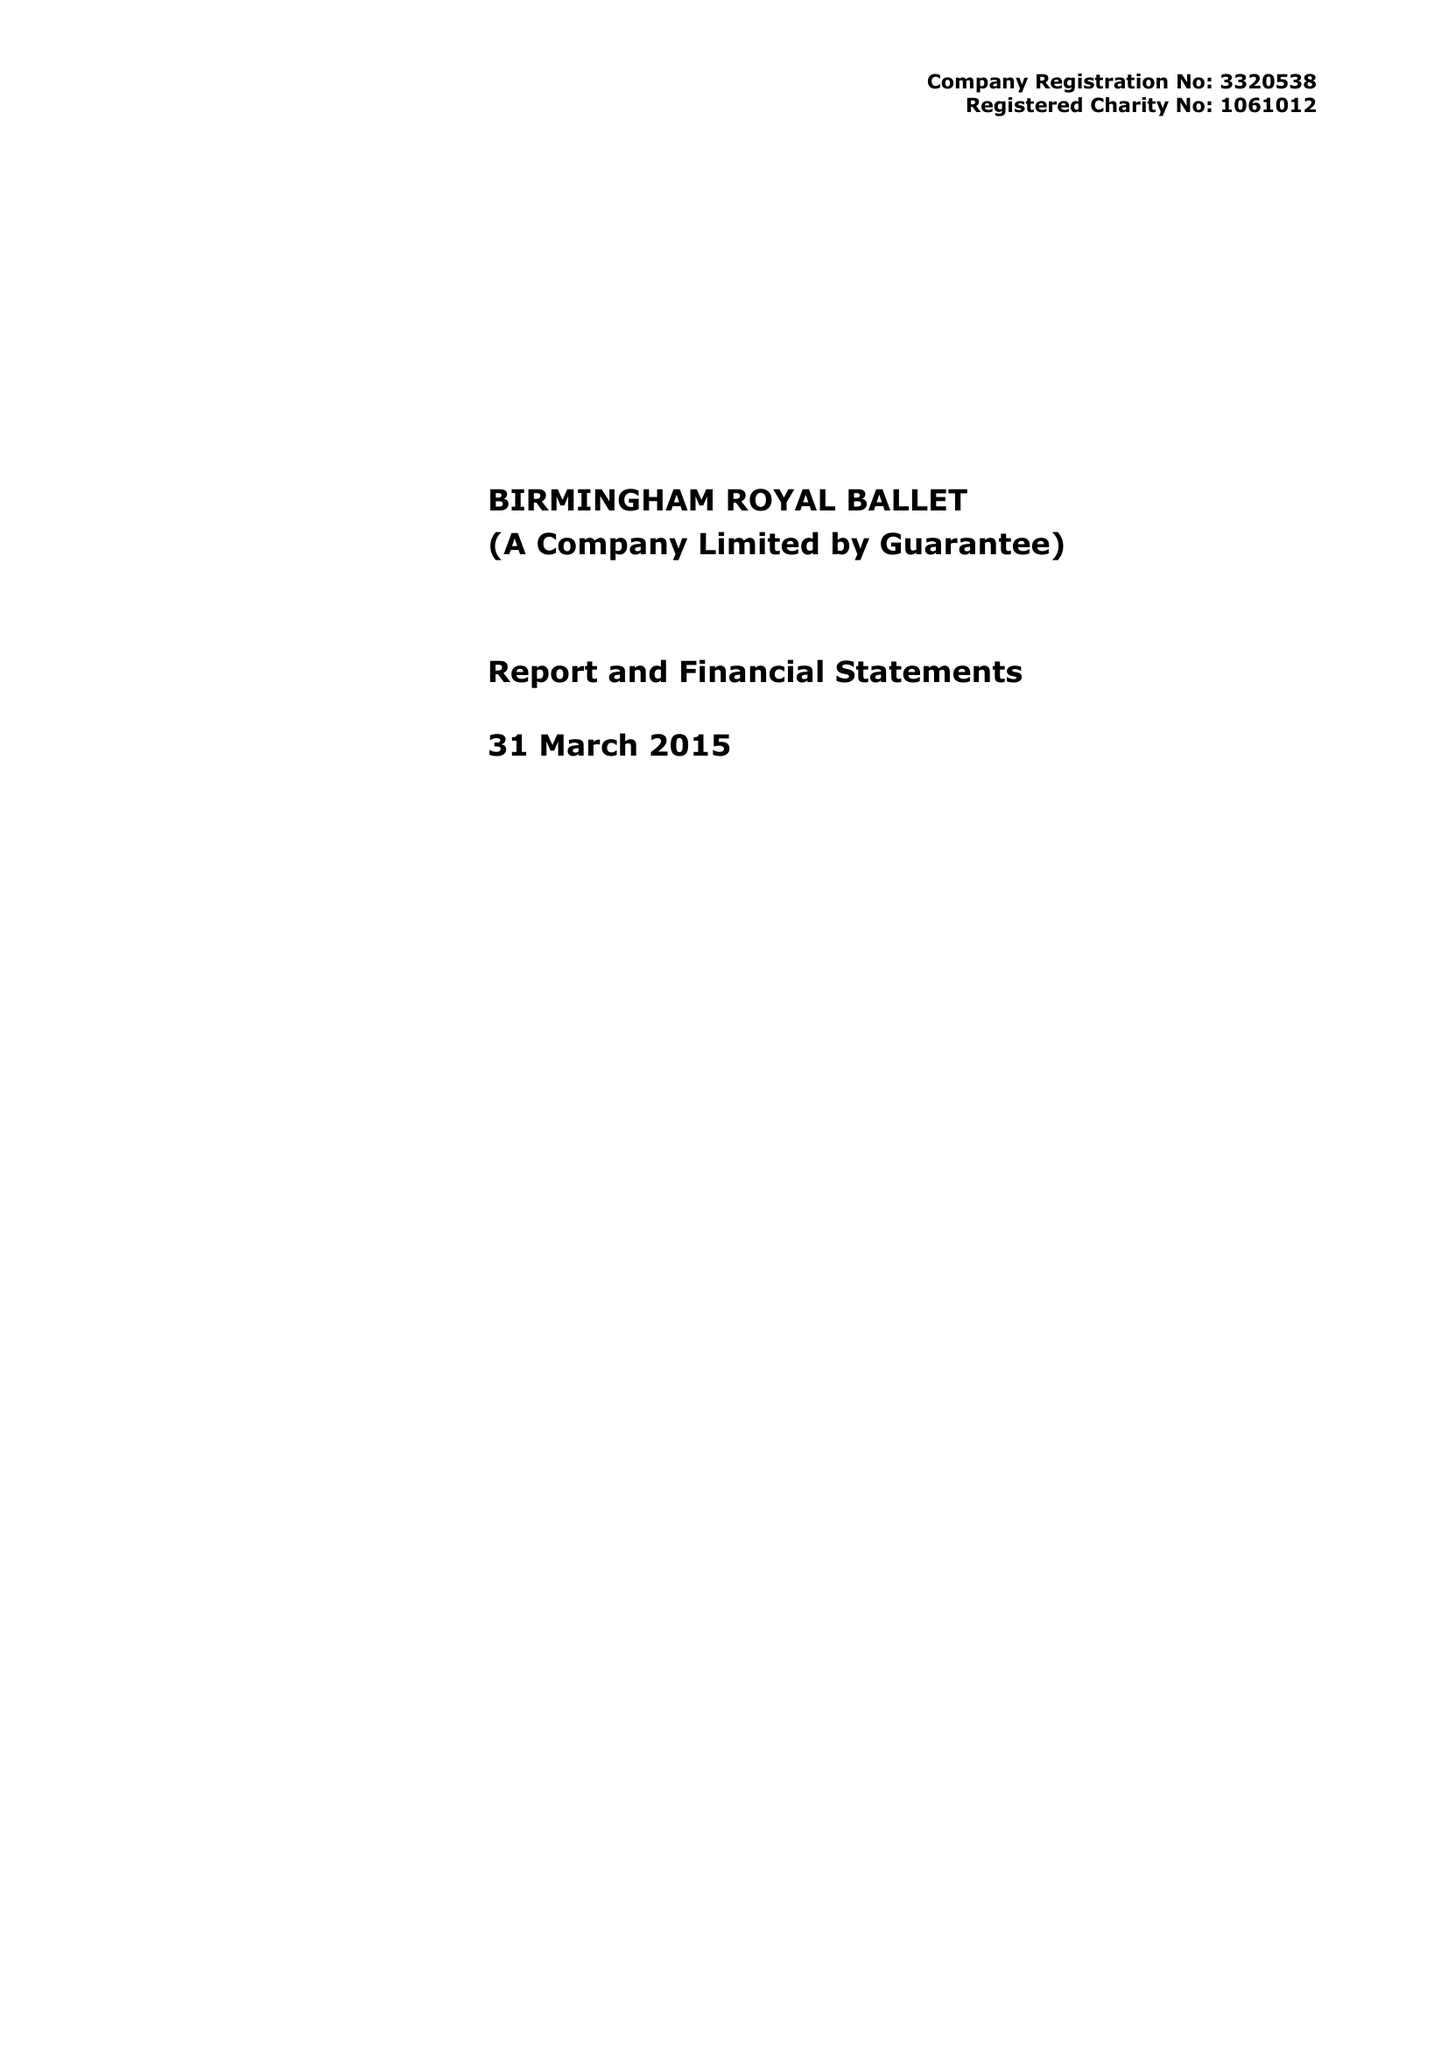What is the value for the address__postcode?
Answer the question using a single word or phrase. B5 4AU 